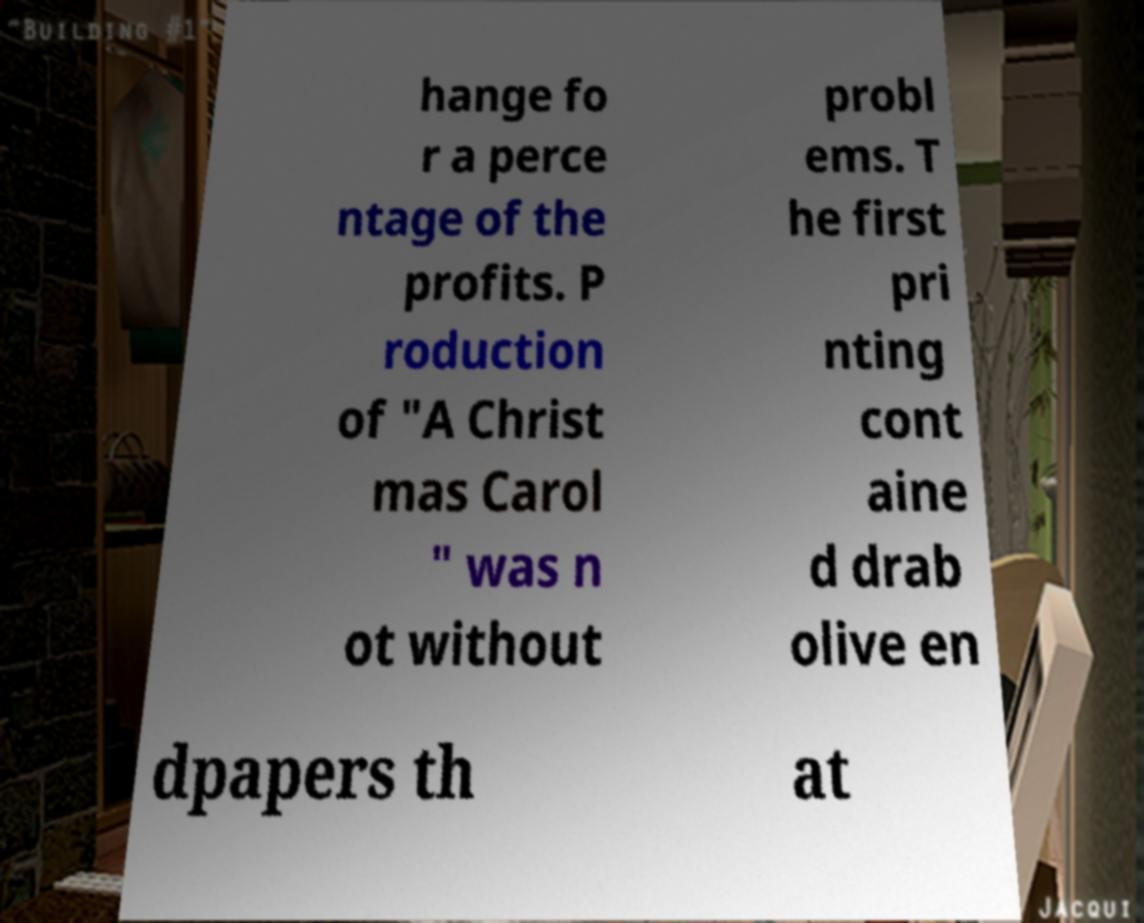What messages or text are displayed in this image? I need them in a readable, typed format. hange fo r a perce ntage of the profits. P roduction of "A Christ mas Carol " was n ot without probl ems. T he first pri nting cont aine d drab olive en dpapers th at 